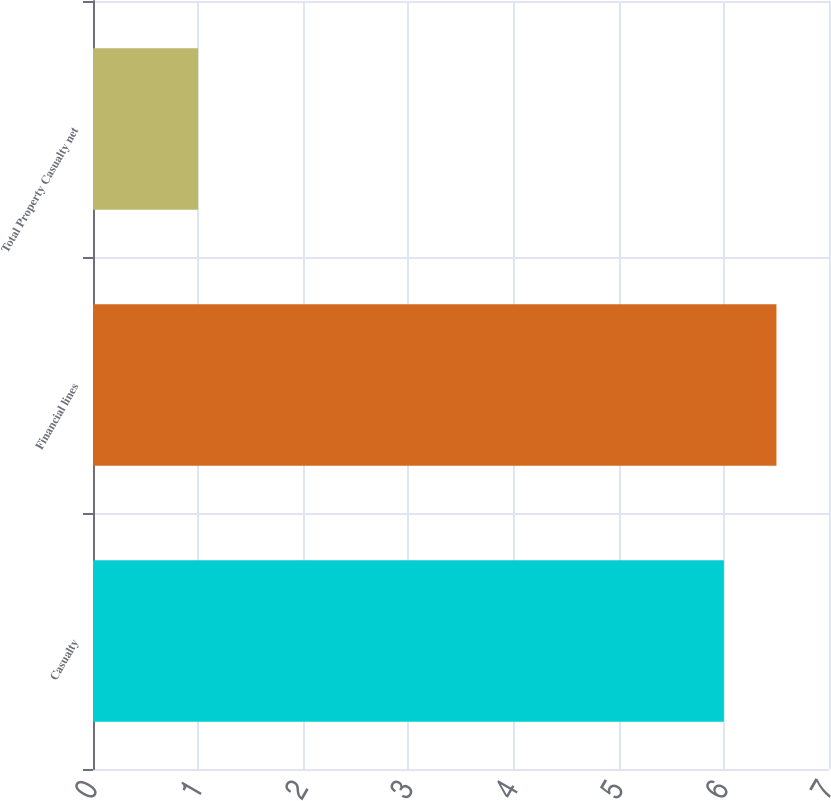Convert chart. <chart><loc_0><loc_0><loc_500><loc_500><bar_chart><fcel>Casualty<fcel>Financial lines<fcel>Total Property Casualty net<nl><fcel>6<fcel>6.5<fcel>1<nl></chart> 